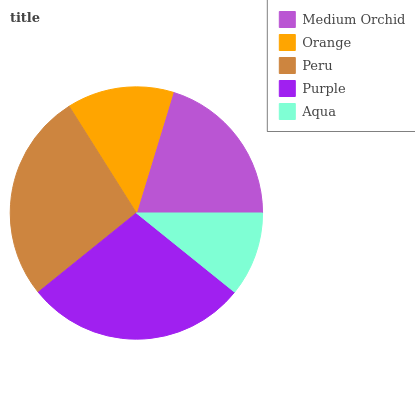Is Aqua the minimum?
Answer yes or no. Yes. Is Purple the maximum?
Answer yes or no. Yes. Is Orange the minimum?
Answer yes or no. No. Is Orange the maximum?
Answer yes or no. No. Is Medium Orchid greater than Orange?
Answer yes or no. Yes. Is Orange less than Medium Orchid?
Answer yes or no. Yes. Is Orange greater than Medium Orchid?
Answer yes or no. No. Is Medium Orchid less than Orange?
Answer yes or no. No. Is Medium Orchid the high median?
Answer yes or no. Yes. Is Medium Orchid the low median?
Answer yes or no. Yes. Is Peru the high median?
Answer yes or no. No. Is Orange the low median?
Answer yes or no. No. 